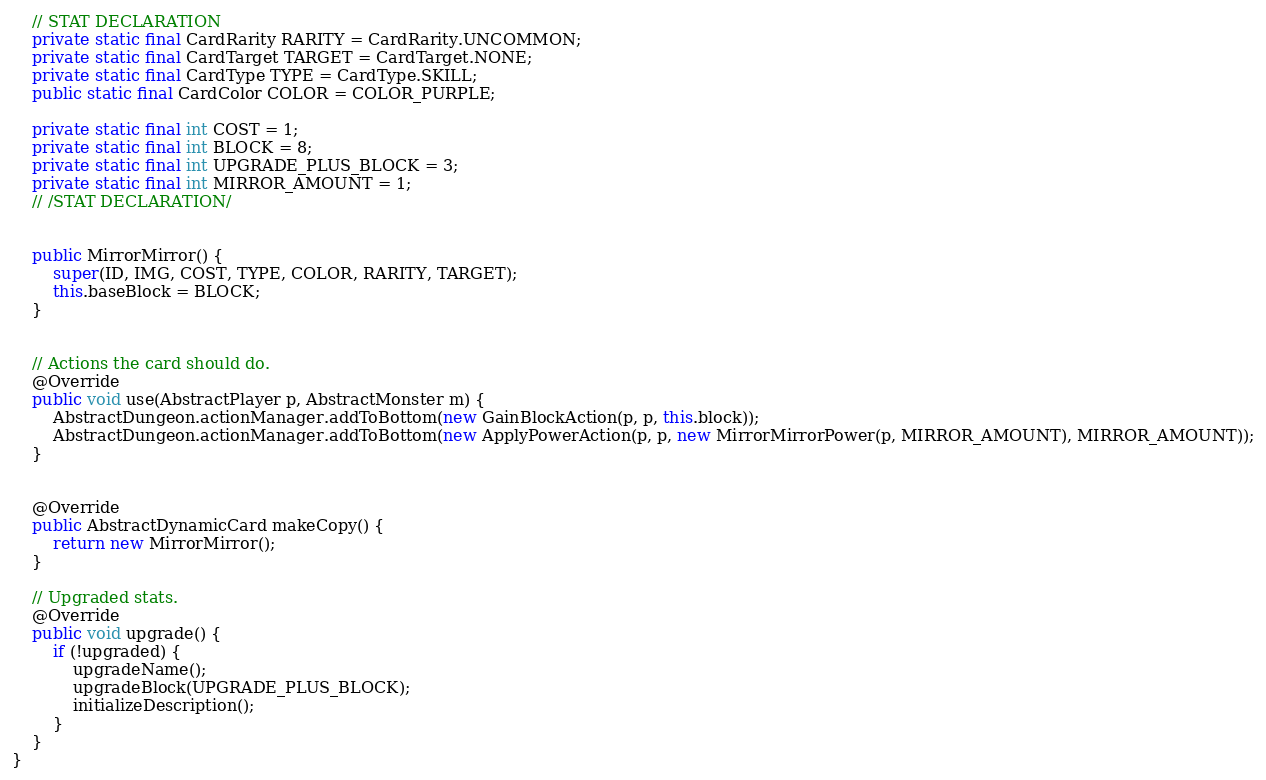<code> <loc_0><loc_0><loc_500><loc_500><_Java_>
    // STAT DECLARATION
    private static final CardRarity RARITY = CardRarity.UNCOMMON;
    private static final CardTarget TARGET = CardTarget.NONE;
    private static final CardType TYPE = CardType.SKILL;
    public static final CardColor COLOR = COLOR_PURPLE;

    private static final int COST = 1;
    private static final int BLOCK = 8;
    private static final int UPGRADE_PLUS_BLOCK = 3;
    private static final int MIRROR_AMOUNT = 1;
    // /STAT DECLARATION/


    public MirrorMirror() {
        super(ID, IMG, COST, TYPE, COLOR, RARITY, TARGET);
        this.baseBlock = BLOCK;
    }


    // Actions the card should do.
    @Override
    public void use(AbstractPlayer p, AbstractMonster m) {
        AbstractDungeon.actionManager.addToBottom(new GainBlockAction(p, p, this.block));
        AbstractDungeon.actionManager.addToBottom(new ApplyPowerAction(p, p, new MirrorMirrorPower(p, MIRROR_AMOUNT), MIRROR_AMOUNT));
    }


    @Override
    public AbstractDynamicCard makeCopy() {
        return new MirrorMirror();
    }

    // Upgraded stats.
    @Override
    public void upgrade() {
        if (!upgraded) {
            upgradeName();
            upgradeBlock(UPGRADE_PLUS_BLOCK);
            initializeDescription();
        }
    }
}
</code> 